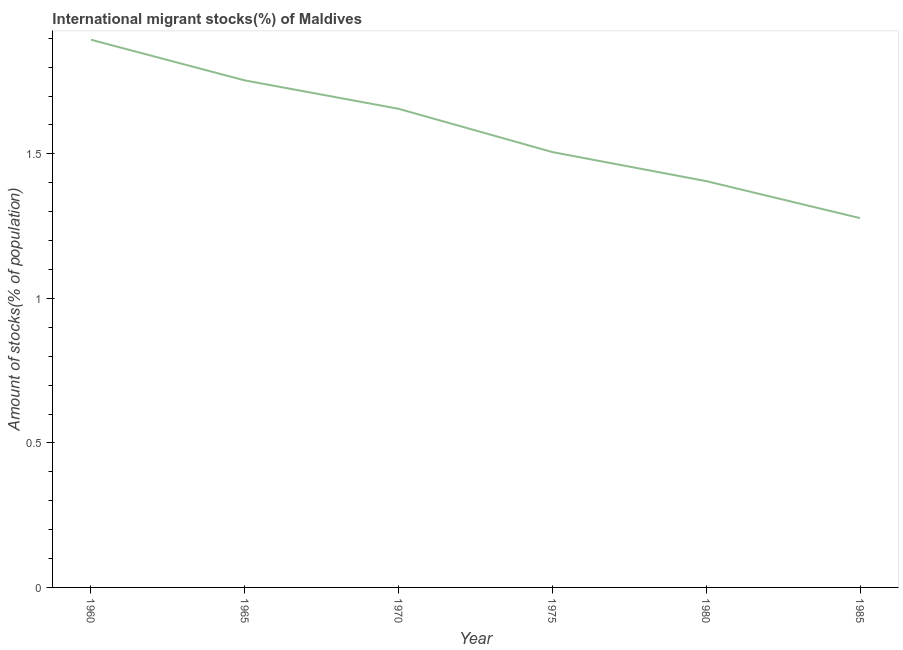What is the number of international migrant stocks in 1985?
Make the answer very short. 1.28. Across all years, what is the maximum number of international migrant stocks?
Provide a short and direct response. 1.89. Across all years, what is the minimum number of international migrant stocks?
Provide a short and direct response. 1.28. In which year was the number of international migrant stocks minimum?
Offer a terse response. 1985. What is the sum of the number of international migrant stocks?
Offer a terse response. 9.49. What is the difference between the number of international migrant stocks in 1975 and 1985?
Keep it short and to the point. 0.23. What is the average number of international migrant stocks per year?
Offer a very short reply. 1.58. What is the median number of international migrant stocks?
Offer a very short reply. 1.58. In how many years, is the number of international migrant stocks greater than 1.2 %?
Provide a short and direct response. 6. Do a majority of the years between 1960 and 1985 (inclusive) have number of international migrant stocks greater than 1.7 %?
Your answer should be compact. No. What is the ratio of the number of international migrant stocks in 1970 to that in 1980?
Your answer should be compact. 1.18. Is the number of international migrant stocks in 1970 less than that in 1980?
Your answer should be very brief. No. Is the difference between the number of international migrant stocks in 1970 and 1985 greater than the difference between any two years?
Make the answer very short. No. What is the difference between the highest and the second highest number of international migrant stocks?
Your answer should be very brief. 0.14. Is the sum of the number of international migrant stocks in 1970 and 1980 greater than the maximum number of international migrant stocks across all years?
Provide a short and direct response. Yes. What is the difference between the highest and the lowest number of international migrant stocks?
Give a very brief answer. 0.62. What is the difference between two consecutive major ticks on the Y-axis?
Make the answer very short. 0.5. Does the graph contain any zero values?
Ensure brevity in your answer.  No. Does the graph contain grids?
Your answer should be very brief. No. What is the title of the graph?
Your response must be concise. International migrant stocks(%) of Maldives. What is the label or title of the Y-axis?
Provide a short and direct response. Amount of stocks(% of population). What is the Amount of stocks(% of population) of 1960?
Give a very brief answer. 1.89. What is the Amount of stocks(% of population) in 1965?
Your answer should be compact. 1.75. What is the Amount of stocks(% of population) of 1970?
Ensure brevity in your answer.  1.66. What is the Amount of stocks(% of population) in 1975?
Make the answer very short. 1.51. What is the Amount of stocks(% of population) in 1980?
Keep it short and to the point. 1.41. What is the Amount of stocks(% of population) of 1985?
Ensure brevity in your answer.  1.28. What is the difference between the Amount of stocks(% of population) in 1960 and 1965?
Provide a succinct answer. 0.14. What is the difference between the Amount of stocks(% of population) in 1960 and 1970?
Provide a short and direct response. 0.24. What is the difference between the Amount of stocks(% of population) in 1960 and 1975?
Your response must be concise. 0.39. What is the difference between the Amount of stocks(% of population) in 1960 and 1980?
Give a very brief answer. 0.49. What is the difference between the Amount of stocks(% of population) in 1960 and 1985?
Offer a terse response. 0.62. What is the difference between the Amount of stocks(% of population) in 1965 and 1970?
Your answer should be compact. 0.1. What is the difference between the Amount of stocks(% of population) in 1965 and 1975?
Offer a terse response. 0.25. What is the difference between the Amount of stocks(% of population) in 1965 and 1980?
Make the answer very short. 0.35. What is the difference between the Amount of stocks(% of population) in 1965 and 1985?
Provide a succinct answer. 0.48. What is the difference between the Amount of stocks(% of population) in 1970 and 1975?
Give a very brief answer. 0.15. What is the difference between the Amount of stocks(% of population) in 1970 and 1980?
Your answer should be very brief. 0.25. What is the difference between the Amount of stocks(% of population) in 1970 and 1985?
Provide a short and direct response. 0.38. What is the difference between the Amount of stocks(% of population) in 1975 and 1980?
Provide a short and direct response. 0.1. What is the difference between the Amount of stocks(% of population) in 1975 and 1985?
Your answer should be very brief. 0.23. What is the difference between the Amount of stocks(% of population) in 1980 and 1985?
Your answer should be very brief. 0.13. What is the ratio of the Amount of stocks(% of population) in 1960 to that in 1970?
Give a very brief answer. 1.14. What is the ratio of the Amount of stocks(% of population) in 1960 to that in 1975?
Make the answer very short. 1.26. What is the ratio of the Amount of stocks(% of population) in 1960 to that in 1980?
Your answer should be very brief. 1.35. What is the ratio of the Amount of stocks(% of population) in 1960 to that in 1985?
Provide a succinct answer. 1.48. What is the ratio of the Amount of stocks(% of population) in 1965 to that in 1970?
Provide a succinct answer. 1.06. What is the ratio of the Amount of stocks(% of population) in 1965 to that in 1975?
Keep it short and to the point. 1.17. What is the ratio of the Amount of stocks(% of population) in 1965 to that in 1980?
Keep it short and to the point. 1.25. What is the ratio of the Amount of stocks(% of population) in 1965 to that in 1985?
Offer a terse response. 1.37. What is the ratio of the Amount of stocks(% of population) in 1970 to that in 1975?
Make the answer very short. 1.1. What is the ratio of the Amount of stocks(% of population) in 1970 to that in 1980?
Your answer should be compact. 1.18. What is the ratio of the Amount of stocks(% of population) in 1970 to that in 1985?
Your answer should be very brief. 1.3. What is the ratio of the Amount of stocks(% of population) in 1975 to that in 1980?
Offer a very short reply. 1.07. What is the ratio of the Amount of stocks(% of population) in 1975 to that in 1985?
Make the answer very short. 1.18. What is the ratio of the Amount of stocks(% of population) in 1980 to that in 1985?
Give a very brief answer. 1.1. 